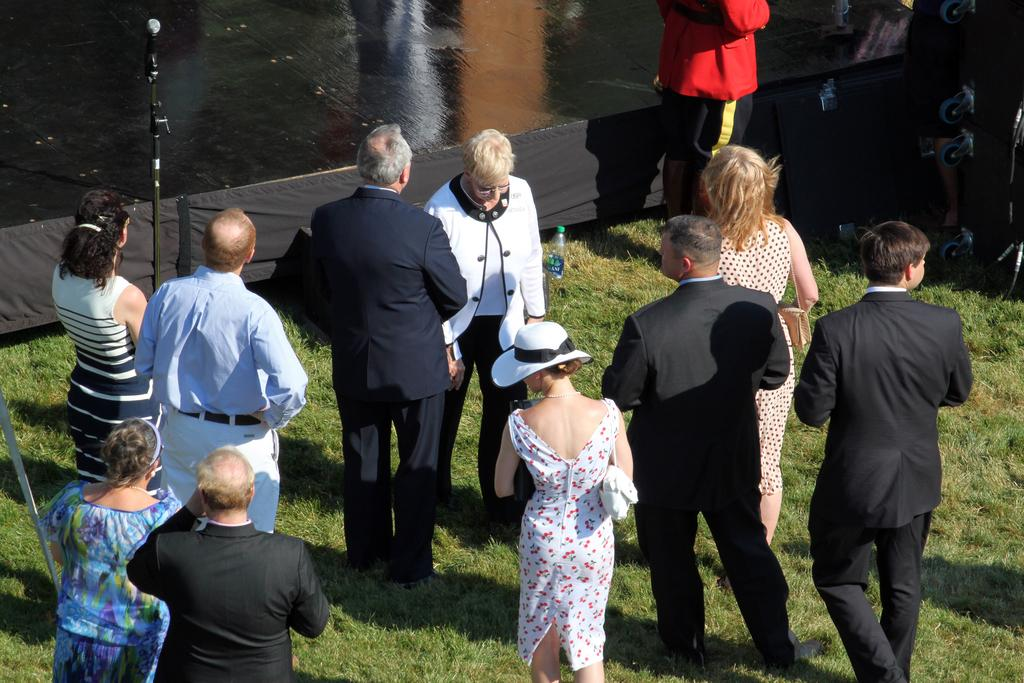What is the primary setting of the image? There are people on the ground in the image, suggesting an outdoor or open space. What object can be seen near the people? There is a bottle visible in the image. What equipment is present in the image? There is a mic with a stand in the image. What type of vegetation is visible in the image? There is grass in the image. What other unspecified objects can be seen in the image? There are some unspecified objects in the image, but we cannot identify them based on the provided facts. What can be seen in the background of the image? There is a fence and a floor visible in the background of the image. How many apples are on the shelf in the image? There is no shelf or apples present in the image. Is the boy wearing a hat in the image? There is no boy present in the image. 